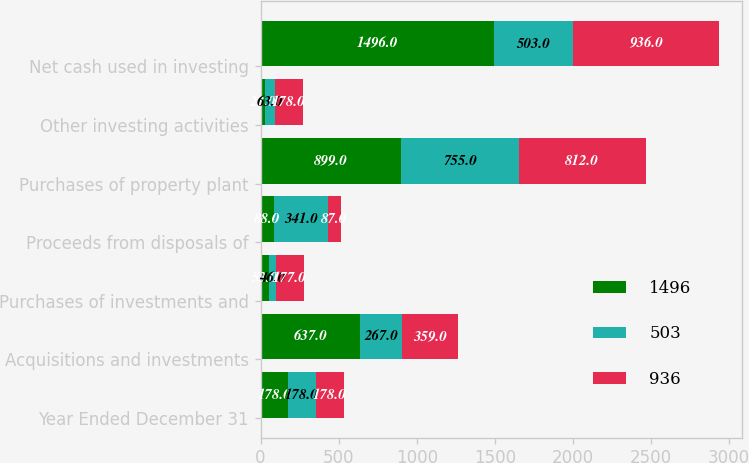Convert chart. <chart><loc_0><loc_0><loc_500><loc_500><stacked_bar_chart><ecel><fcel>Year Ended December 31<fcel>Acquisitions and investments<fcel>Purchases of investments and<fcel>Proceeds from disposals of<fcel>Purchases of property plant<fcel>Other investing activities<fcel>Net cash used in investing<nl><fcel>1496<fcel>178<fcel>637<fcel>53<fcel>88<fcel>899<fcel>28<fcel>1496<nl><fcel>503<fcel>178<fcel>267<fcel>46<fcel>341<fcel>755<fcel>63<fcel>503<nl><fcel>936<fcel>178<fcel>359<fcel>177<fcel>87<fcel>812<fcel>178<fcel>936<nl></chart> 